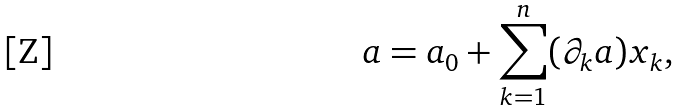<formula> <loc_0><loc_0><loc_500><loc_500>a = a _ { 0 } + \sum _ { k = 1 } ^ { n } ( \partial _ { k } a ) x _ { k } ,</formula> 